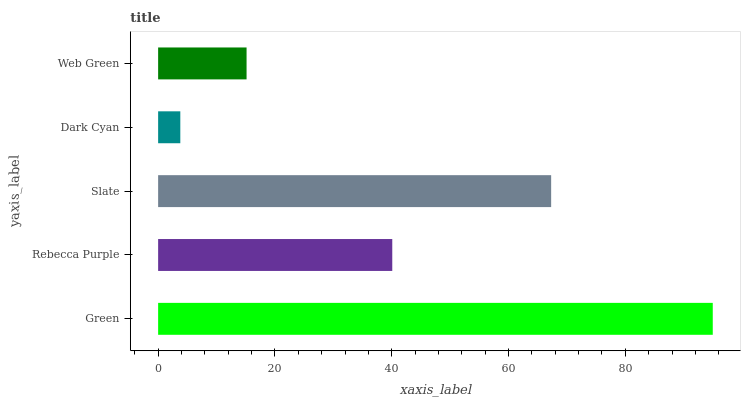Is Dark Cyan the minimum?
Answer yes or no. Yes. Is Green the maximum?
Answer yes or no. Yes. Is Rebecca Purple the minimum?
Answer yes or no. No. Is Rebecca Purple the maximum?
Answer yes or no. No. Is Green greater than Rebecca Purple?
Answer yes or no. Yes. Is Rebecca Purple less than Green?
Answer yes or no. Yes. Is Rebecca Purple greater than Green?
Answer yes or no. No. Is Green less than Rebecca Purple?
Answer yes or no. No. Is Rebecca Purple the high median?
Answer yes or no. Yes. Is Rebecca Purple the low median?
Answer yes or no. Yes. Is Dark Cyan the high median?
Answer yes or no. No. Is Green the low median?
Answer yes or no. No. 